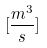<formula> <loc_0><loc_0><loc_500><loc_500>[ \frac { m ^ { 3 } } { s } ]</formula> 